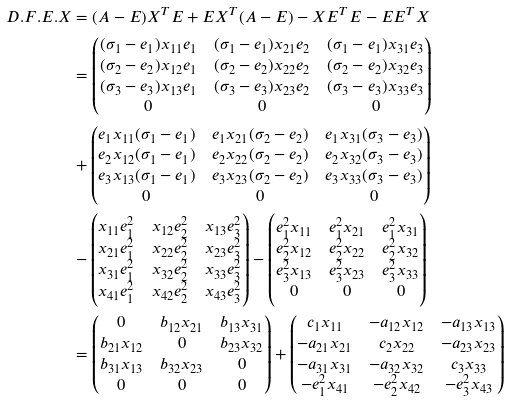<formula> <loc_0><loc_0><loc_500><loc_500>D . F . E . X & = ( A - E ) X ^ { T } E + E X ^ { T } ( A - E ) - X E ^ { T } E - E E ^ { T } X \\ & = \begin{pmatrix} ( \sigma _ { 1 } - e _ { 1 } ) x _ { 1 1 } e _ { 1 } & ( \sigma _ { 1 } - e _ { 1 } ) x _ { 2 1 } e _ { 2 } & ( \sigma _ { 1 } - e _ { 1 } ) x _ { 3 1 } e _ { 3 } \\ ( \sigma _ { 2 } - e _ { 2 } ) x _ { 1 2 } e _ { 1 } & ( \sigma _ { 2 } - e _ { 2 } ) x _ { 2 2 } e _ { 2 } & ( \sigma _ { 2 } - e _ { 2 } ) x _ { 3 2 } e _ { 3 } \\ ( \sigma _ { 3 } - e _ { 3 } ) x _ { 1 3 } e _ { 1 } & ( \sigma _ { 3 } - e _ { 3 } ) x _ { 2 3 } e _ { 2 } & ( \sigma _ { 3 } - e _ { 3 } ) x _ { 3 3 } e _ { 3 } \\ 0 & 0 & 0 \end{pmatrix} \\ & + \begin{pmatrix} e _ { 1 } x _ { 1 1 } ( \sigma _ { 1 } - e _ { 1 } ) & e _ { 1 } x _ { 2 1 } ( \sigma _ { 2 } - e _ { 2 } ) & e _ { 1 } x _ { 3 1 } ( \sigma _ { 3 } - e _ { 3 } ) \\ e _ { 2 } x _ { 1 2 } ( \sigma _ { 1 } - e _ { 1 } ) & e _ { 2 } x _ { 2 2 } ( \sigma _ { 2 } - e _ { 2 } ) & e _ { 2 } x _ { 3 2 } ( \sigma _ { 3 } - e _ { 3 } ) \\ e _ { 3 } x _ { 1 3 } ( \sigma _ { 1 } - e _ { 1 } ) & e _ { 3 } x _ { 2 3 } ( \sigma _ { 2 } - e _ { 2 } ) & e _ { 3 } x _ { 3 3 } ( \sigma _ { 3 } - e _ { 3 } ) \\ 0 & 0 & 0 \end{pmatrix} \\ & - \begin{pmatrix} x _ { 1 1 } e _ { 1 } ^ { 2 } & x _ { 1 2 } e _ { 2 } ^ { 2 } & x _ { 1 3 } e _ { 3 } ^ { 2 } \\ x _ { 2 1 } e _ { 1 } ^ { 2 } & x _ { 2 2 } e _ { 2 } ^ { 2 } & x _ { 2 3 } e _ { 3 } ^ { 2 } \\ x _ { 3 1 } e _ { 1 } ^ { 2 } & x _ { 3 2 } e _ { 2 } ^ { 2 } & x _ { 3 3 } e _ { 3 } ^ { 2 } \\ x _ { 4 1 } e _ { 1 } ^ { 2 } & x _ { 4 2 } e _ { 2 } ^ { 2 } & x _ { 4 3 } e _ { 3 } ^ { 2 } \end{pmatrix} - \begin{pmatrix} e _ { 1 } ^ { 2 } x _ { 1 1 } & e _ { 1 } ^ { 2 } x _ { 2 1 } & e _ { 1 } ^ { 2 } x _ { 3 1 } \\ e _ { 2 } ^ { 2 } x _ { 1 2 } & e _ { 2 } ^ { 2 } x _ { 2 2 } & e _ { 2 } ^ { 2 } x _ { 3 2 } \\ e _ { 3 } ^ { 2 } x _ { 1 3 } & e _ { 3 } ^ { 2 } x _ { 2 3 } & e _ { 3 } ^ { 2 } x _ { 3 3 } \\ 0 & 0 & 0 \end{pmatrix} \\ & = \begin{pmatrix} 0 & b _ { 1 2 } x _ { 2 1 } & b _ { 1 3 } x _ { 3 1 } \\ b _ { 2 1 } x _ { 1 2 } & 0 & b _ { 2 3 } x _ { 3 2 } \\ b _ { 3 1 } x _ { 1 3 } & b _ { 3 2 } x _ { 2 3 } & 0 \\ 0 & 0 & 0 \end{pmatrix} + \begin{pmatrix} c _ { 1 } x _ { 1 1 } & - a _ { 1 2 } x _ { 1 2 } & - a _ { 1 3 } x _ { 1 3 } \\ - a _ { 2 1 } x _ { 2 1 } & c _ { 2 } x _ { 2 2 } & - a _ { 2 3 } x _ { 2 3 } \\ - a _ { 3 1 } x _ { 3 1 } & - a _ { 3 2 } x _ { 3 2 } & c _ { 3 } x _ { 3 3 } \\ - e _ { 1 } ^ { 2 } x _ { 4 1 } & - e _ { 2 } ^ { 2 } x _ { 4 2 } & - e _ { 3 } ^ { 2 } x _ { 4 3 } \end{pmatrix}</formula> 